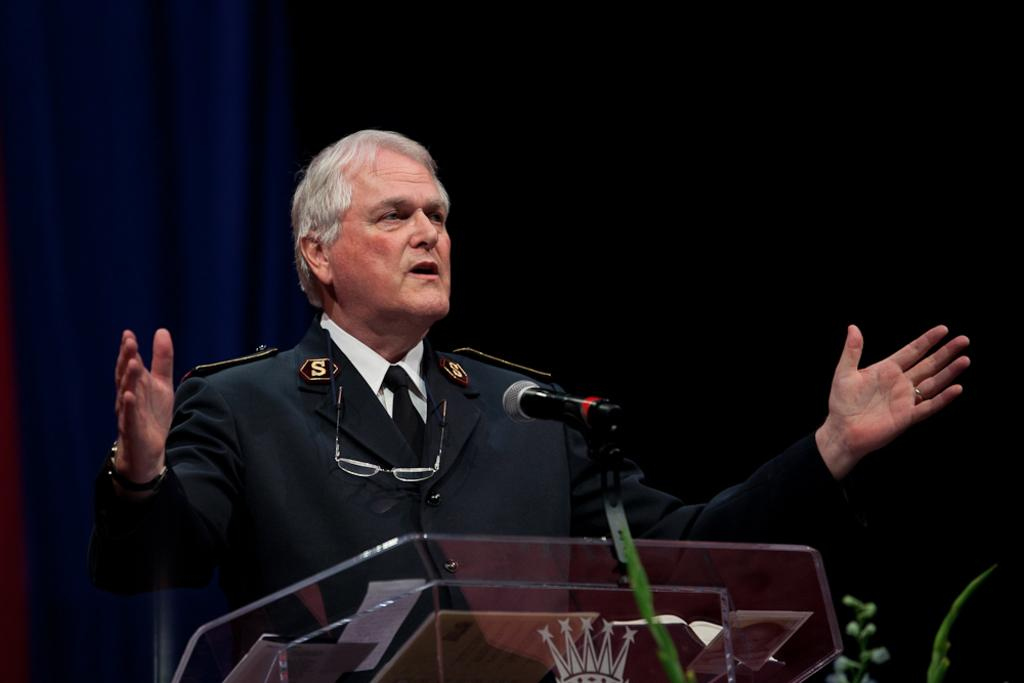What is the person in the image doing? The person is standing in front of the dais. What object is visible in front of the person? There is a microphone in front of the image. What type of decoration can be seen at the back of the image? There are curtains at the back side of the image. Can you tell me how many flowers are on the kite in the image? There is no kite or flowers present in the image. 